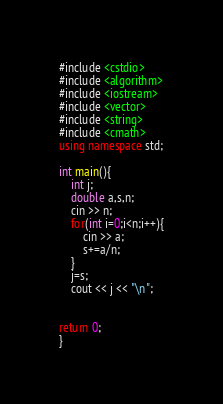Convert code to text. <code><loc_0><loc_0><loc_500><loc_500><_C++_>#include <cstdio>
#include <algorithm>
#include <iostream>
#include <vector>
#include <string>
#include <cmath>
using namespace std;

int main(){
	int j;
	double a,s,n;
	cin >> n;
	for(int i=0;i<n;i++){
		cin >> a;
		s+=a/n;
	}
	j=s;
	cout << j << "\n";
	
	
return 0;
}</code> 